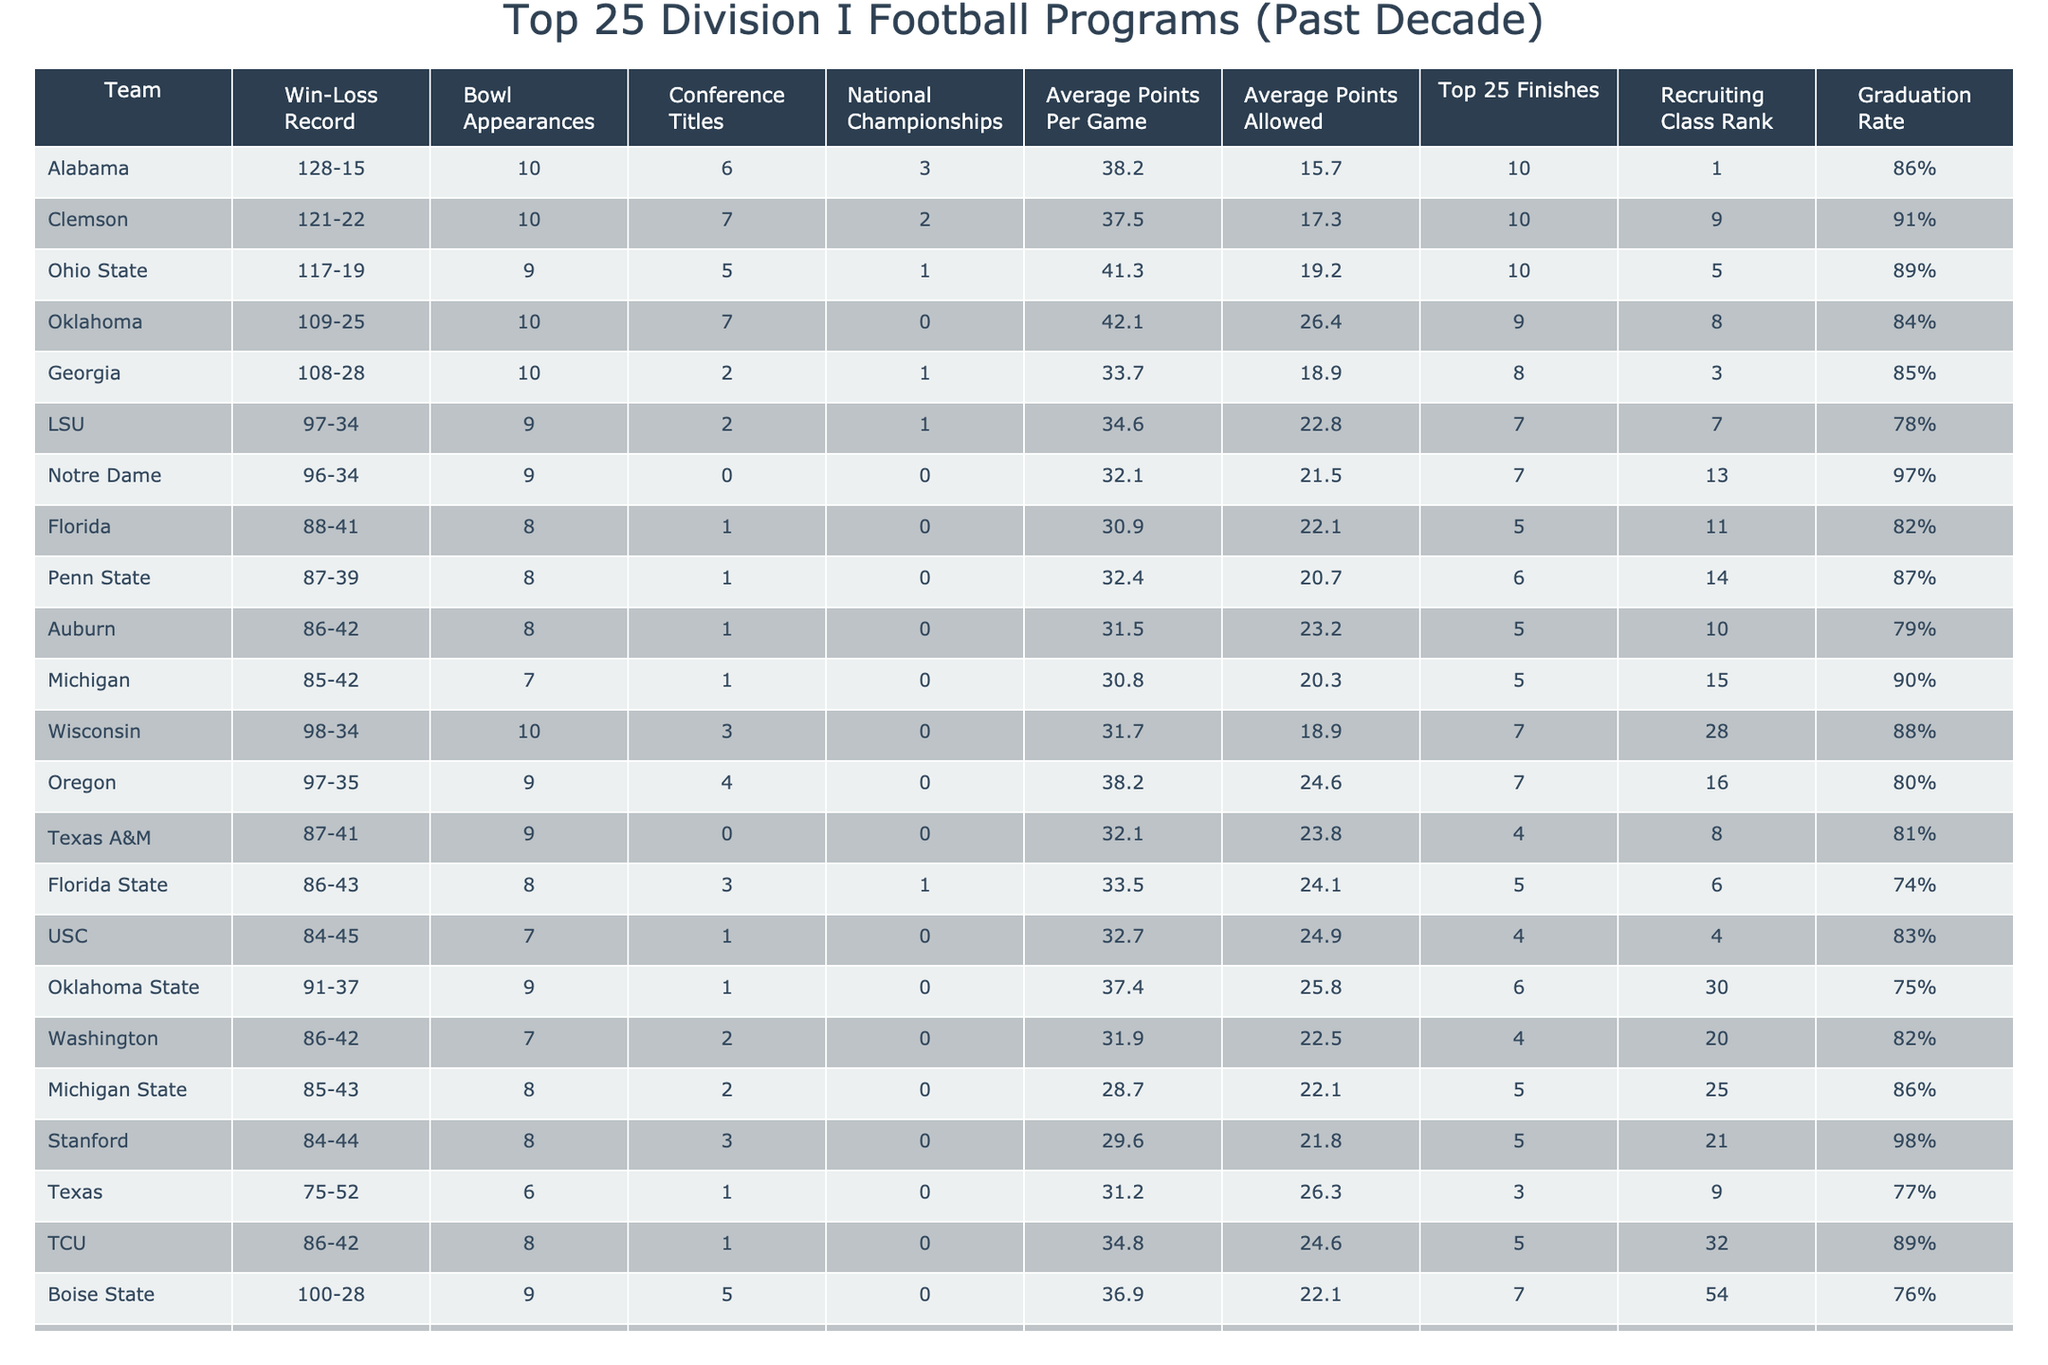What is the win-loss record of Alabama? The table lists Alabama's record as 128 wins and 15 losses.
Answer: 128-15 Which team has the highest average points per game? By checking the "Average Points Per Game" column, Oklahoma has the highest at 42.1 points.
Answer: Oklahoma How many bowl appearances did Clemson make? The table indicates that Clemson had 10 bowl appearances.
Answer: 10 Which team has the lowest graduation rate among the top 25 programs? The "Graduation Rate" column shows that Florida State has the lowest rate at 74%.
Answer: 74% What is the difference in total wins between Ohio State and Florida? Total wins for Ohio State is 117 and for Florida, it is 88. The difference is 117 - 88 = 29 wins.
Answer: 29 Which two teams have the same number of top 25 finishes? The teams with the same number of top 25 finishes (7) are LSU and Notre Dame.
Answer: LSU and Notre Dame Is it true that Georgia has more conference titles than Texas A&M? Georgia has 2 conference titles, while Texas A&M has 0, making the statement true.
Answer: Yes How does Alabama's average points allowed compare to LSU's? Alabama's average points allowed is 15.7 while LSU's is 22.8; thus, Alabama allows 7.1 points fewer than LSU.
Answer: Alabama allows 7.1 points fewer Which program had the highest recruiting class rank in the last decade? Alabama has the highest recruiting class rank at 1st place among all teams listed.
Answer: Alabama What is the average points allowed by the teams that have 9 bowl appearances? The teams with 9 bowl appearances are Oklahoma State, Alabama, Clemson, and Oklahoma. Their average points allowed are 25.8, 15.7, 17.3, and 26.4, leading to an average of (25.8 + 15.7 + 17.3 + 26.4) / 4 = 21.3 points allowed.
Answer: 21.3 Which team had the most national championships in the last decade? Alabama won 3 national championships, which is the most among the listed teams.
Answer: Alabama How many teams have an average of over 35 points per game? The teams with an average greater than 35 points are Alabama, Oklahoma, and Ohio State, totaling 3 teams.
Answer: 3 What is the total number of conference titles won by the top 3 teams? Adding the conference titles for Alabama (6), Clemson (7), and Ohio State (5) gives a total of 6 + 7 + 5 = 18 conference titles.
Answer: 18 Do any of the teams in the table have an undefeated record in bowl games over the last decade? By checking the table, we find that no teams have zero losses in their bowl appearances.
Answer: No Which team has a better average points per game, Wisconsin or TCU? Wisconsin has an average of 31.7 points, while TCU has 34.8 points; hence, TCU has the better average.
Answer: TCU 